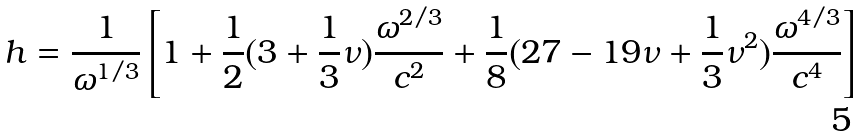<formula> <loc_0><loc_0><loc_500><loc_500>h = \frac { 1 } { \omega ^ { 1 / 3 } } \left [ 1 + \frac { 1 } { 2 } ( 3 + \frac { 1 } { 3 } \nu ) \frac { \omega ^ { 2 / 3 } } { c ^ { 2 } } + \frac { 1 } { 8 } ( 2 7 - 1 9 \nu + \frac { 1 } { 3 } \nu ^ { 2 } ) \frac { \omega ^ { 4 / 3 } } { c ^ { 4 } } \right ] \,</formula> 